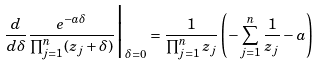Convert formula to latex. <formula><loc_0><loc_0><loc_500><loc_500>\frac { d } { d \delta } \frac { e ^ { - a \delta } } { \prod _ { j = 1 } ^ { n } ( z _ { j } + \delta ) } \Big | _ { \delta = 0 } = \frac { 1 } { \prod _ { j = 1 } ^ { n } z _ { j } } \left ( - \sum _ { j = 1 } ^ { n } \frac { 1 } { z _ { j } } - a \right )</formula> 